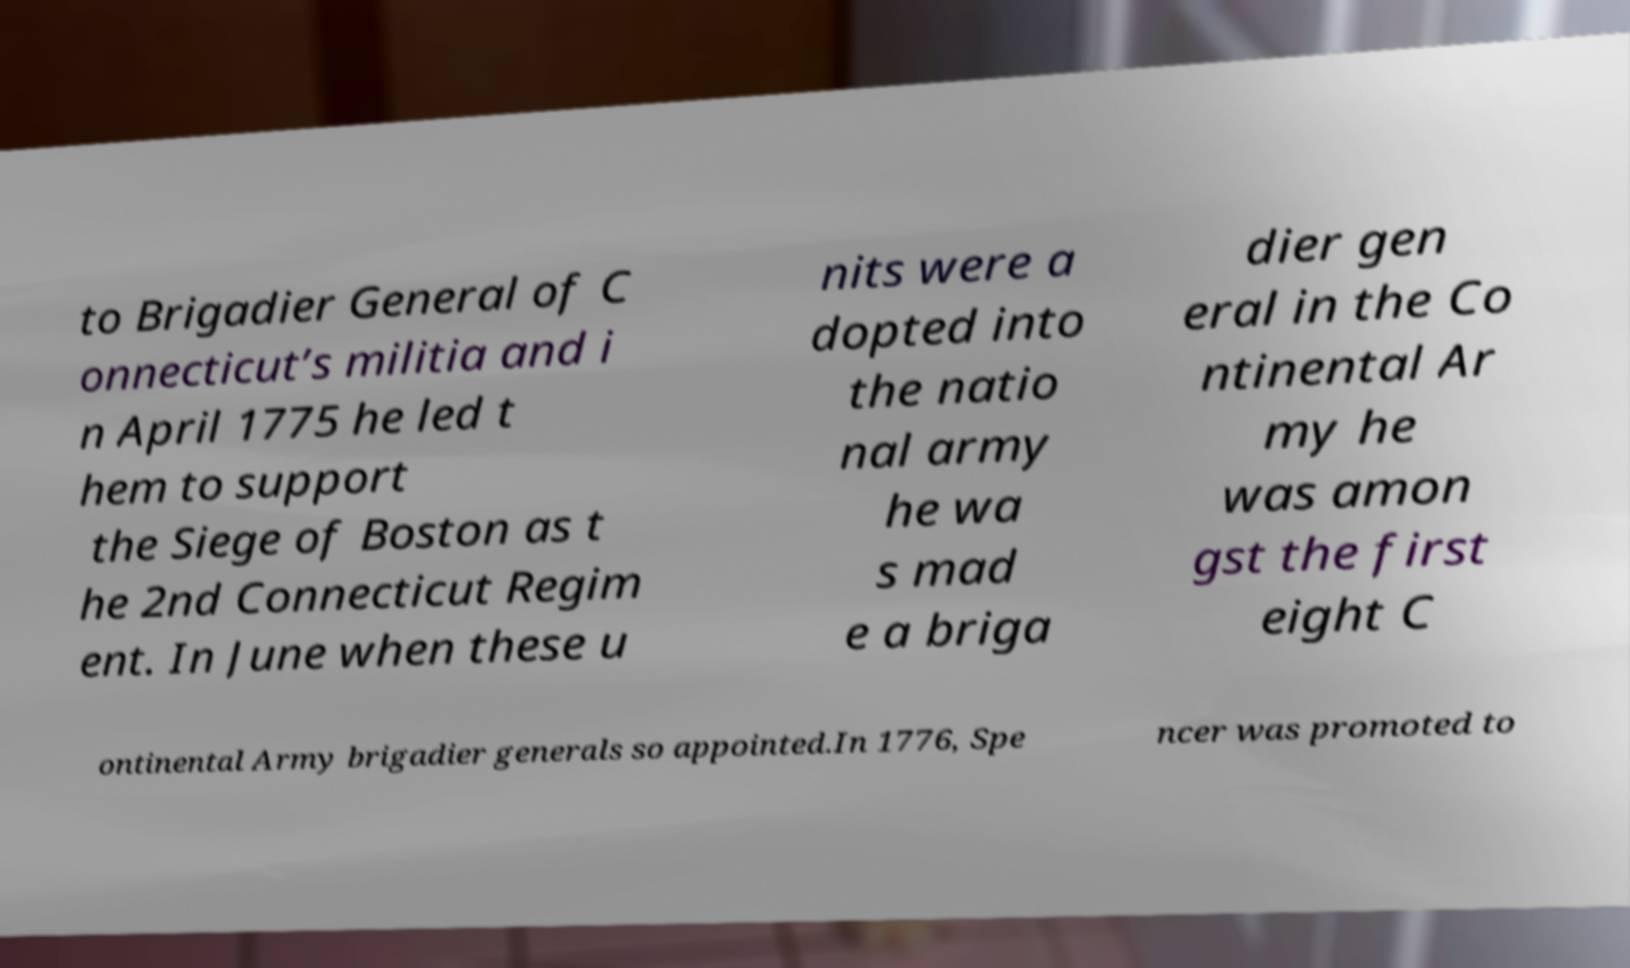There's text embedded in this image that I need extracted. Can you transcribe it verbatim? to Brigadier General of C onnecticut’s militia and i n April 1775 he led t hem to support the Siege of Boston as t he 2nd Connecticut Regim ent. In June when these u nits were a dopted into the natio nal army he wa s mad e a briga dier gen eral in the Co ntinental Ar my he was amon gst the first eight C ontinental Army brigadier generals so appointed.In 1776, Spe ncer was promoted to 